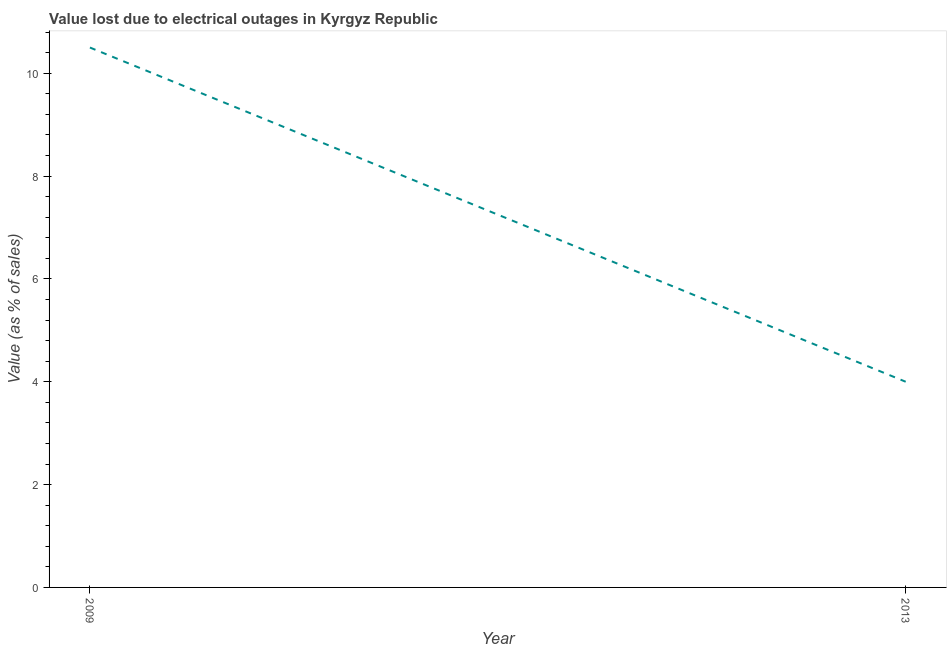In which year was the value lost due to electrical outages maximum?
Offer a terse response. 2009. What is the sum of the value lost due to electrical outages?
Ensure brevity in your answer.  14.5. What is the average value lost due to electrical outages per year?
Ensure brevity in your answer.  7.25. What is the median value lost due to electrical outages?
Provide a succinct answer. 7.25. In how many years, is the value lost due to electrical outages greater than 4 %?
Your answer should be compact. 1. Do a majority of the years between 2013 and 2009 (inclusive) have value lost due to electrical outages greater than 2 %?
Your response must be concise. No. What is the ratio of the value lost due to electrical outages in 2009 to that in 2013?
Ensure brevity in your answer.  2.62. Is the value lost due to electrical outages in 2009 less than that in 2013?
Offer a very short reply. No. Are the values on the major ticks of Y-axis written in scientific E-notation?
Your answer should be compact. No. Does the graph contain any zero values?
Provide a succinct answer. No. Does the graph contain grids?
Make the answer very short. No. What is the title of the graph?
Make the answer very short. Value lost due to electrical outages in Kyrgyz Republic. What is the label or title of the Y-axis?
Make the answer very short. Value (as % of sales). What is the Value (as % of sales) of 2009?
Your answer should be very brief. 10.5. What is the ratio of the Value (as % of sales) in 2009 to that in 2013?
Your response must be concise. 2.62. 